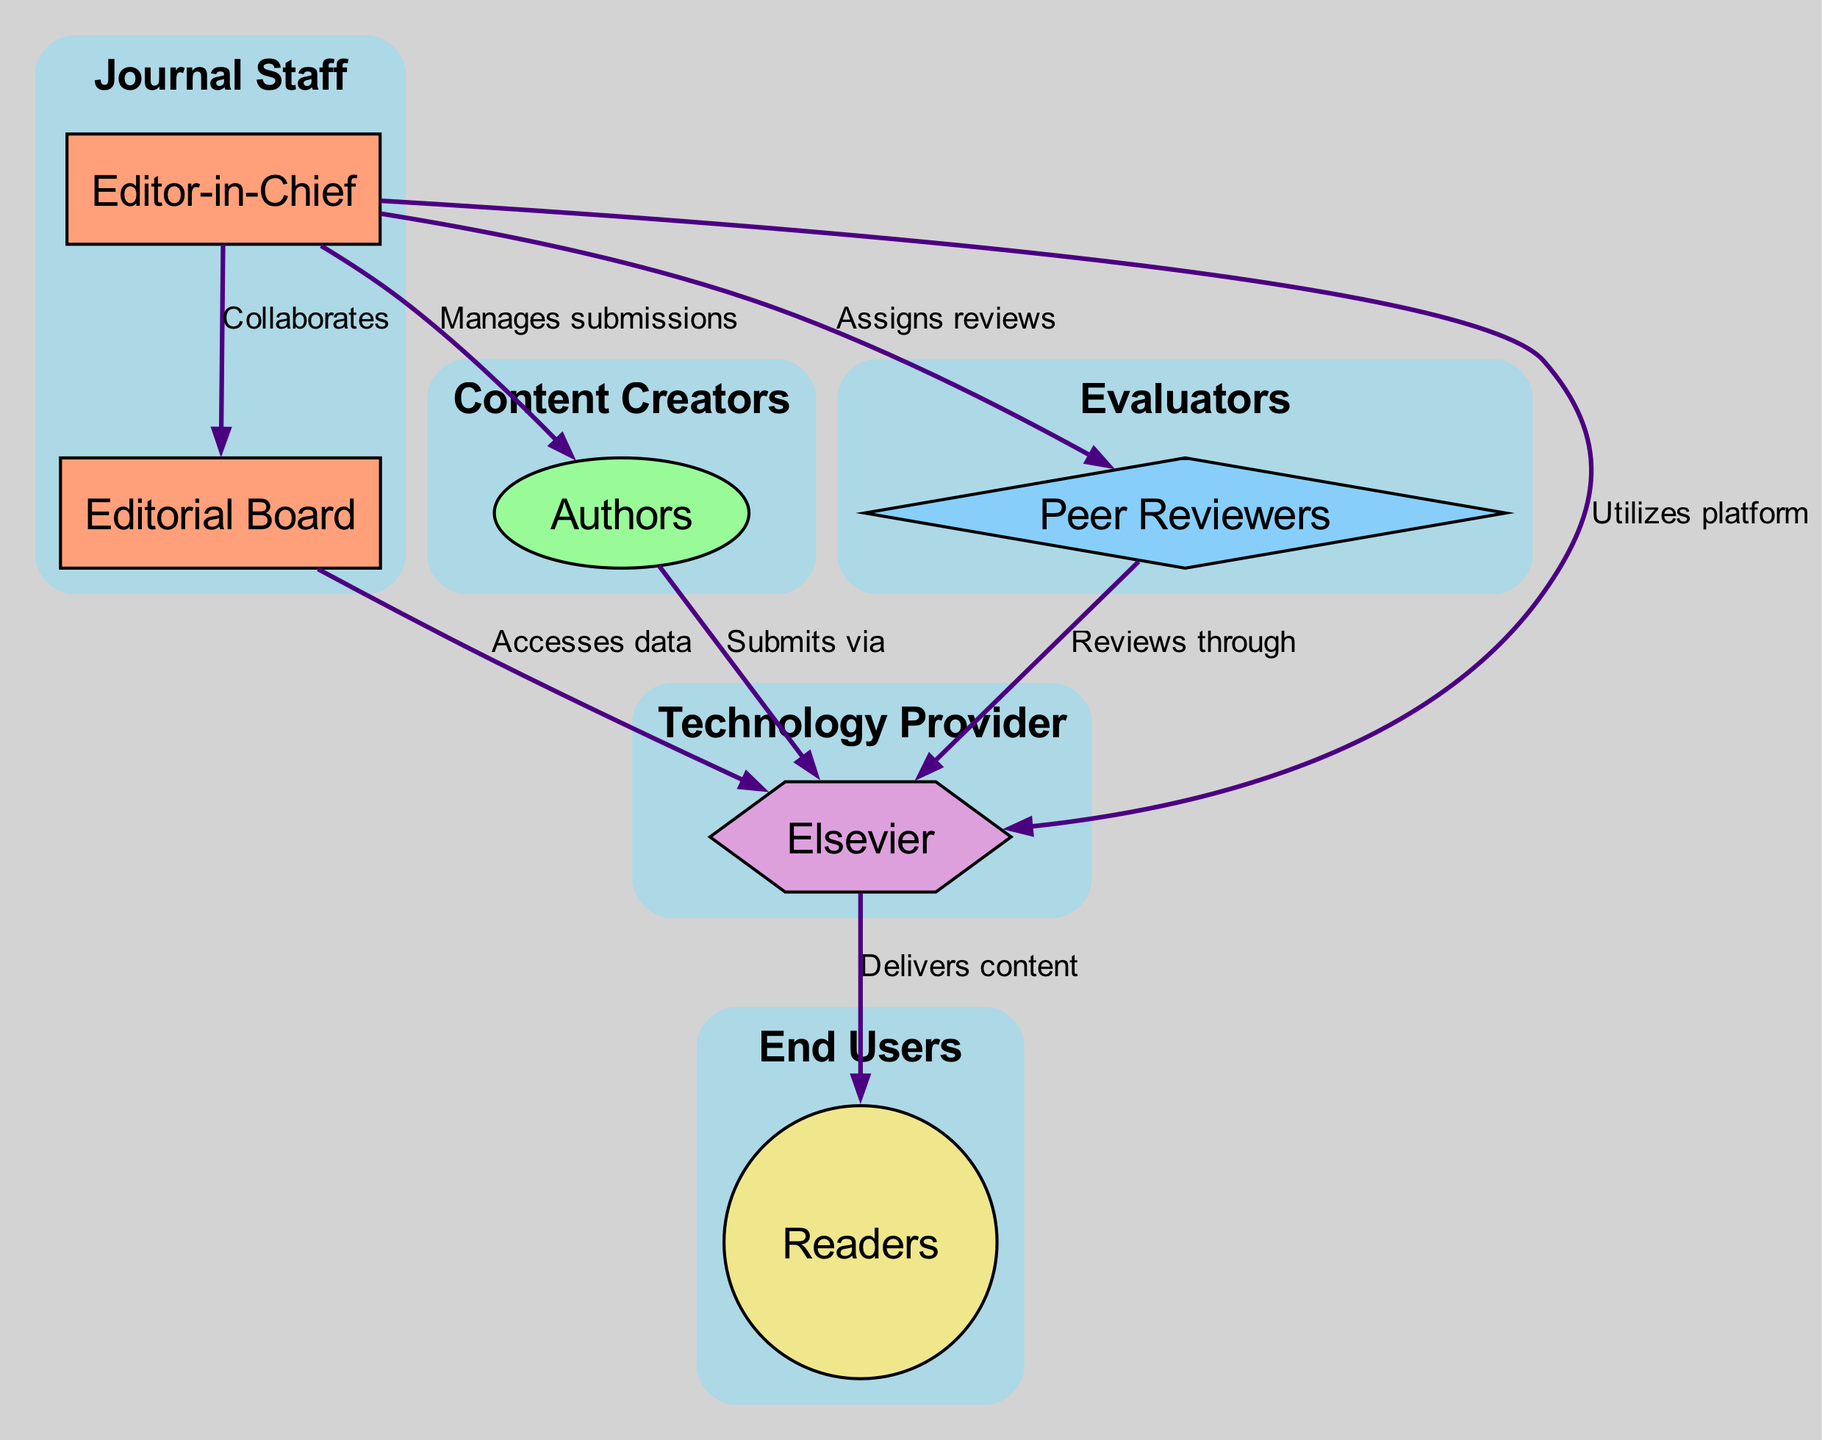What is the total number of nodes in the diagram? By counting the items listed in the 'nodes' section, we have a total of six nodes: Editor-in-Chief, Authors, Peer Reviewers, Editorial Board, Elsevier, and Readers.
Answer: 6 Who does the Editor-in-Chief manage submissions from? The diagram shows a directed edge from the Editor-in-Chief to the Authors labeled "Manages submissions," indicating that the submissions managed by the Editor-in-Chief come from the Authors.
Answer: Authors What type of entity is Elsevier in the diagram? Looking at the category assigned to each node, Elsevier is categorized as a "Technology Provider," reflecting its role in the digital academic publishing ecosystem.
Answer: Technology Provider How many edges are connected to the Readers node? Upon reviewing the edges described, there is one directed edge leading from Elsevier to Readers, showing the relationship that content is delivered to Readers by Elsevier.
Answer: 1 Which node receives content from the Technology Provider? The diagram indicates an edge from Elsevier (the Technology Provider) to Readers, showing that Readers are the recipients of the content delivered by Elsevier.
Answer: Readers What is the relationship between the Editorial Board and the Editor-in-Chief? According to the diagram, the Editor-in-Chief collaborates with the Editorial Board, as shown by the edge labeled "Collaborates" connecting these two nodes.
Answer: Collaborates Who reviews content through the platform provided by the Technology Provider? The Peer Reviewers are shown to have an edge leading to Elsevier with the label "Reviews through," indicating that they utilize the platform provided by Elsevier to conduct their reviews.
Answer: Peer Reviewers How many distinct categories are present in the nodes? By analyzing the categories assigned to each of the six nodes, we find five distinct categories: Journal Staff, Content Creators, Evaluators, Technology Provider, and End Users.
Answer: 5 What action do Authors take related to the Technology Provider? The edge labeled "Submits via" directly connects the Authors to Elsevier, indicating the Authors' action of submitting their work through the technology platform provided by Elsevier.
Answer: Submits via 